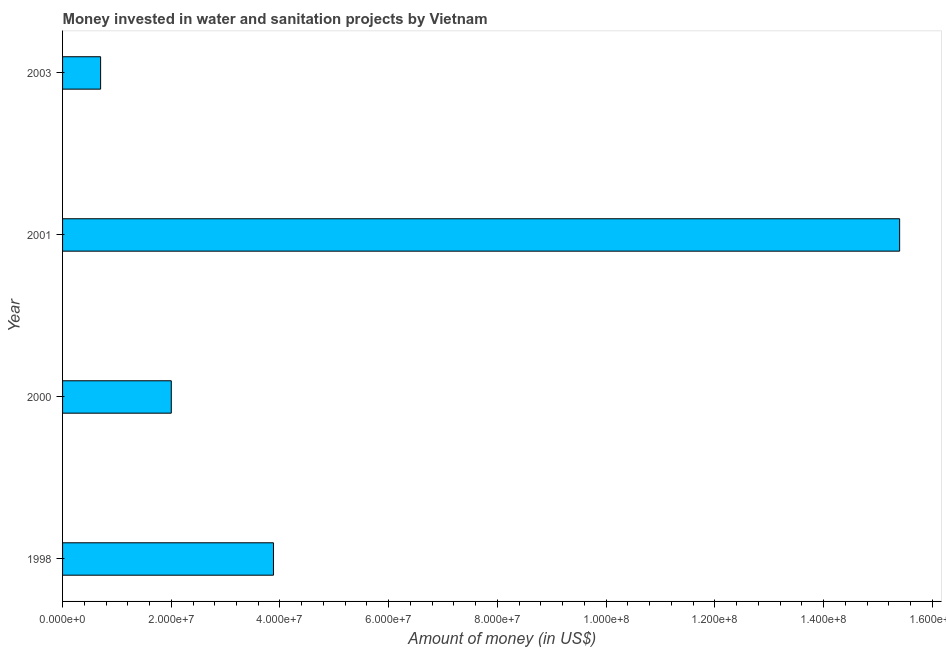Does the graph contain grids?
Keep it short and to the point. No. What is the title of the graph?
Make the answer very short. Money invested in water and sanitation projects by Vietnam. What is the label or title of the X-axis?
Give a very brief answer. Amount of money (in US$). What is the investment in 2000?
Ensure brevity in your answer.  2.00e+07. Across all years, what is the maximum investment?
Offer a very short reply. 1.54e+08. Across all years, what is the minimum investment?
Give a very brief answer. 7.00e+06. In which year was the investment minimum?
Your response must be concise. 2003. What is the sum of the investment?
Ensure brevity in your answer.  2.20e+08. What is the difference between the investment in 2000 and 2003?
Provide a succinct answer. 1.30e+07. What is the average investment per year?
Keep it short and to the point. 5.50e+07. What is the median investment?
Your answer should be compact. 2.94e+07. In how many years, is the investment greater than 76000000 US$?
Provide a short and direct response. 1. What is the ratio of the investment in 1998 to that in 2000?
Make the answer very short. 1.94. Is the difference between the investment in 1998 and 2001 greater than the difference between any two years?
Your answer should be very brief. No. What is the difference between the highest and the second highest investment?
Keep it short and to the point. 1.15e+08. Is the sum of the investment in 2001 and 2003 greater than the maximum investment across all years?
Offer a very short reply. Yes. What is the difference between the highest and the lowest investment?
Your response must be concise. 1.47e+08. How many bars are there?
Offer a terse response. 4. How many years are there in the graph?
Your answer should be compact. 4. What is the Amount of money (in US$) in 1998?
Make the answer very short. 3.88e+07. What is the Amount of money (in US$) in 2001?
Keep it short and to the point. 1.54e+08. What is the difference between the Amount of money (in US$) in 1998 and 2000?
Provide a succinct answer. 1.88e+07. What is the difference between the Amount of money (in US$) in 1998 and 2001?
Give a very brief answer. -1.15e+08. What is the difference between the Amount of money (in US$) in 1998 and 2003?
Make the answer very short. 3.18e+07. What is the difference between the Amount of money (in US$) in 2000 and 2001?
Provide a succinct answer. -1.34e+08. What is the difference between the Amount of money (in US$) in 2000 and 2003?
Your answer should be very brief. 1.30e+07. What is the difference between the Amount of money (in US$) in 2001 and 2003?
Ensure brevity in your answer.  1.47e+08. What is the ratio of the Amount of money (in US$) in 1998 to that in 2000?
Offer a terse response. 1.94. What is the ratio of the Amount of money (in US$) in 1998 to that in 2001?
Your answer should be very brief. 0.25. What is the ratio of the Amount of money (in US$) in 1998 to that in 2003?
Offer a very short reply. 5.54. What is the ratio of the Amount of money (in US$) in 2000 to that in 2001?
Your answer should be compact. 0.13. What is the ratio of the Amount of money (in US$) in 2000 to that in 2003?
Offer a terse response. 2.86. 